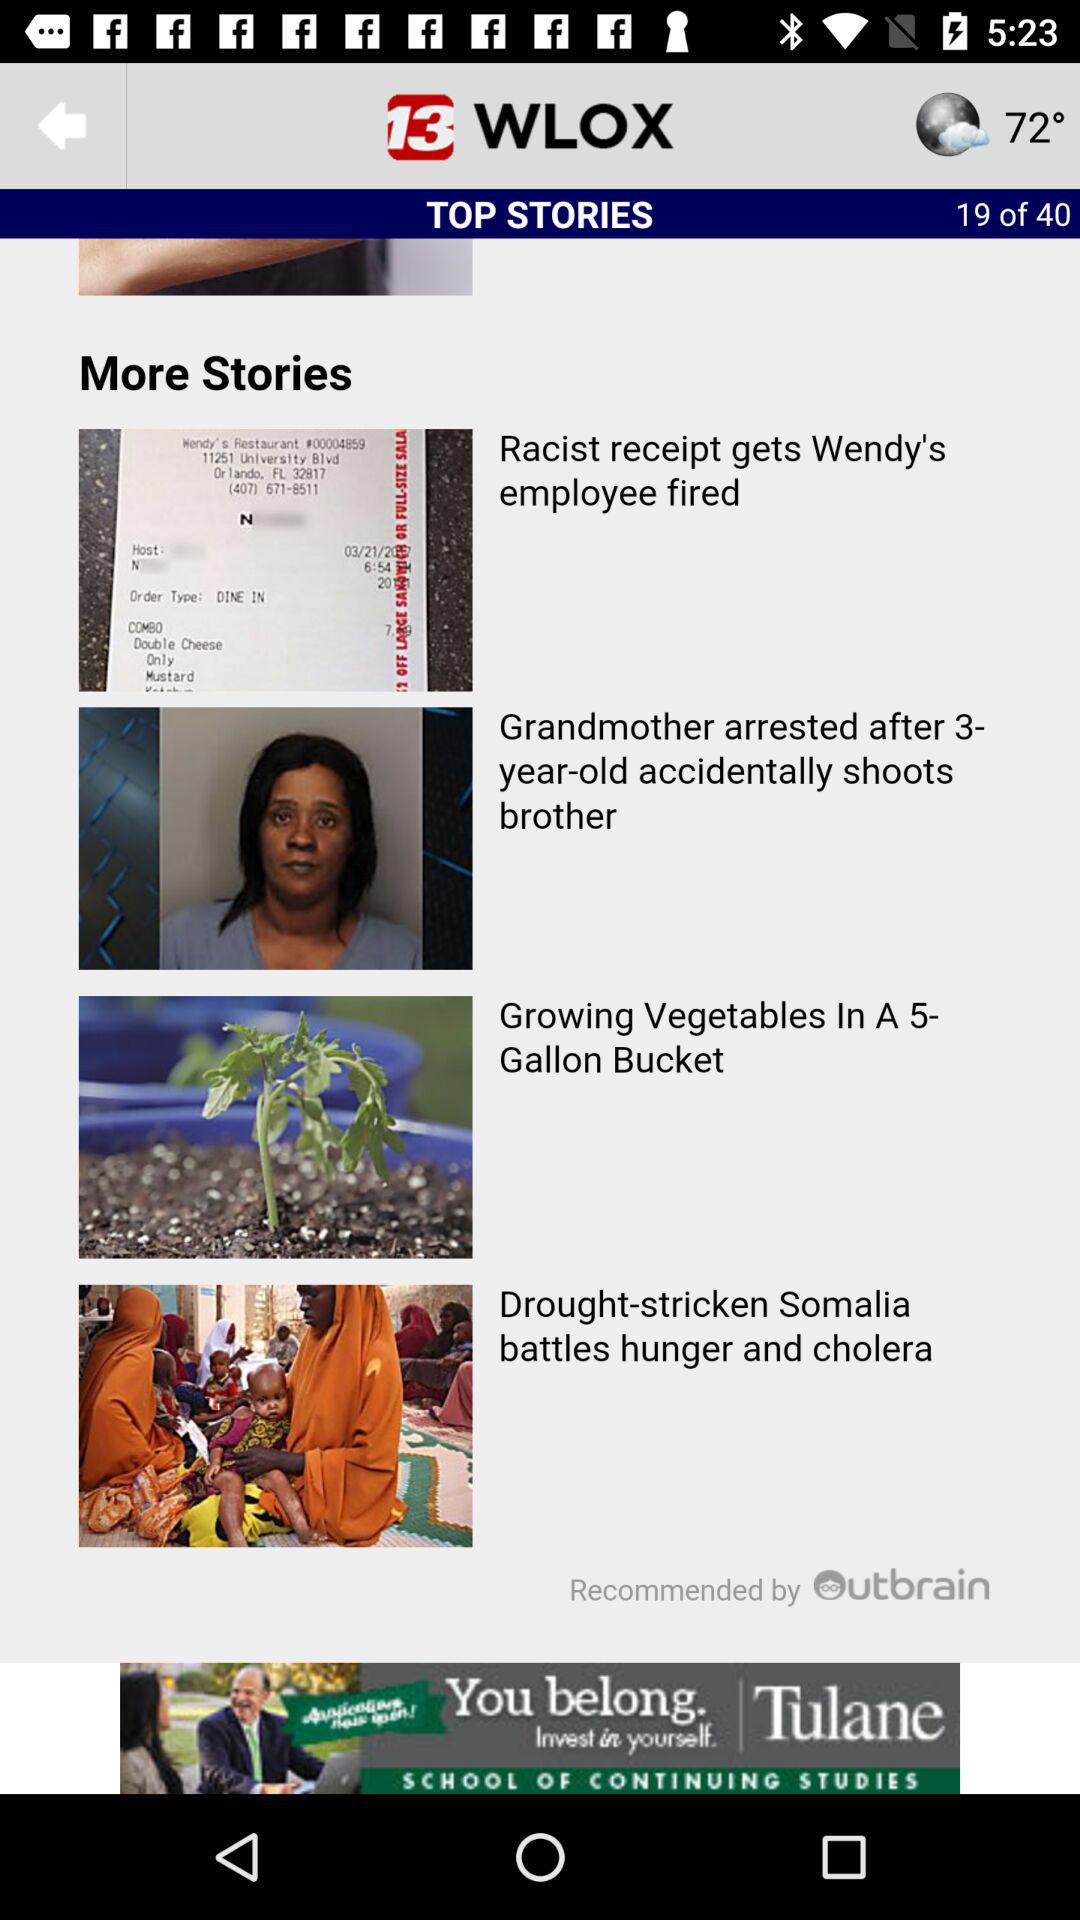What is the news channel name? The name of the news channel is "13 WLOX". 